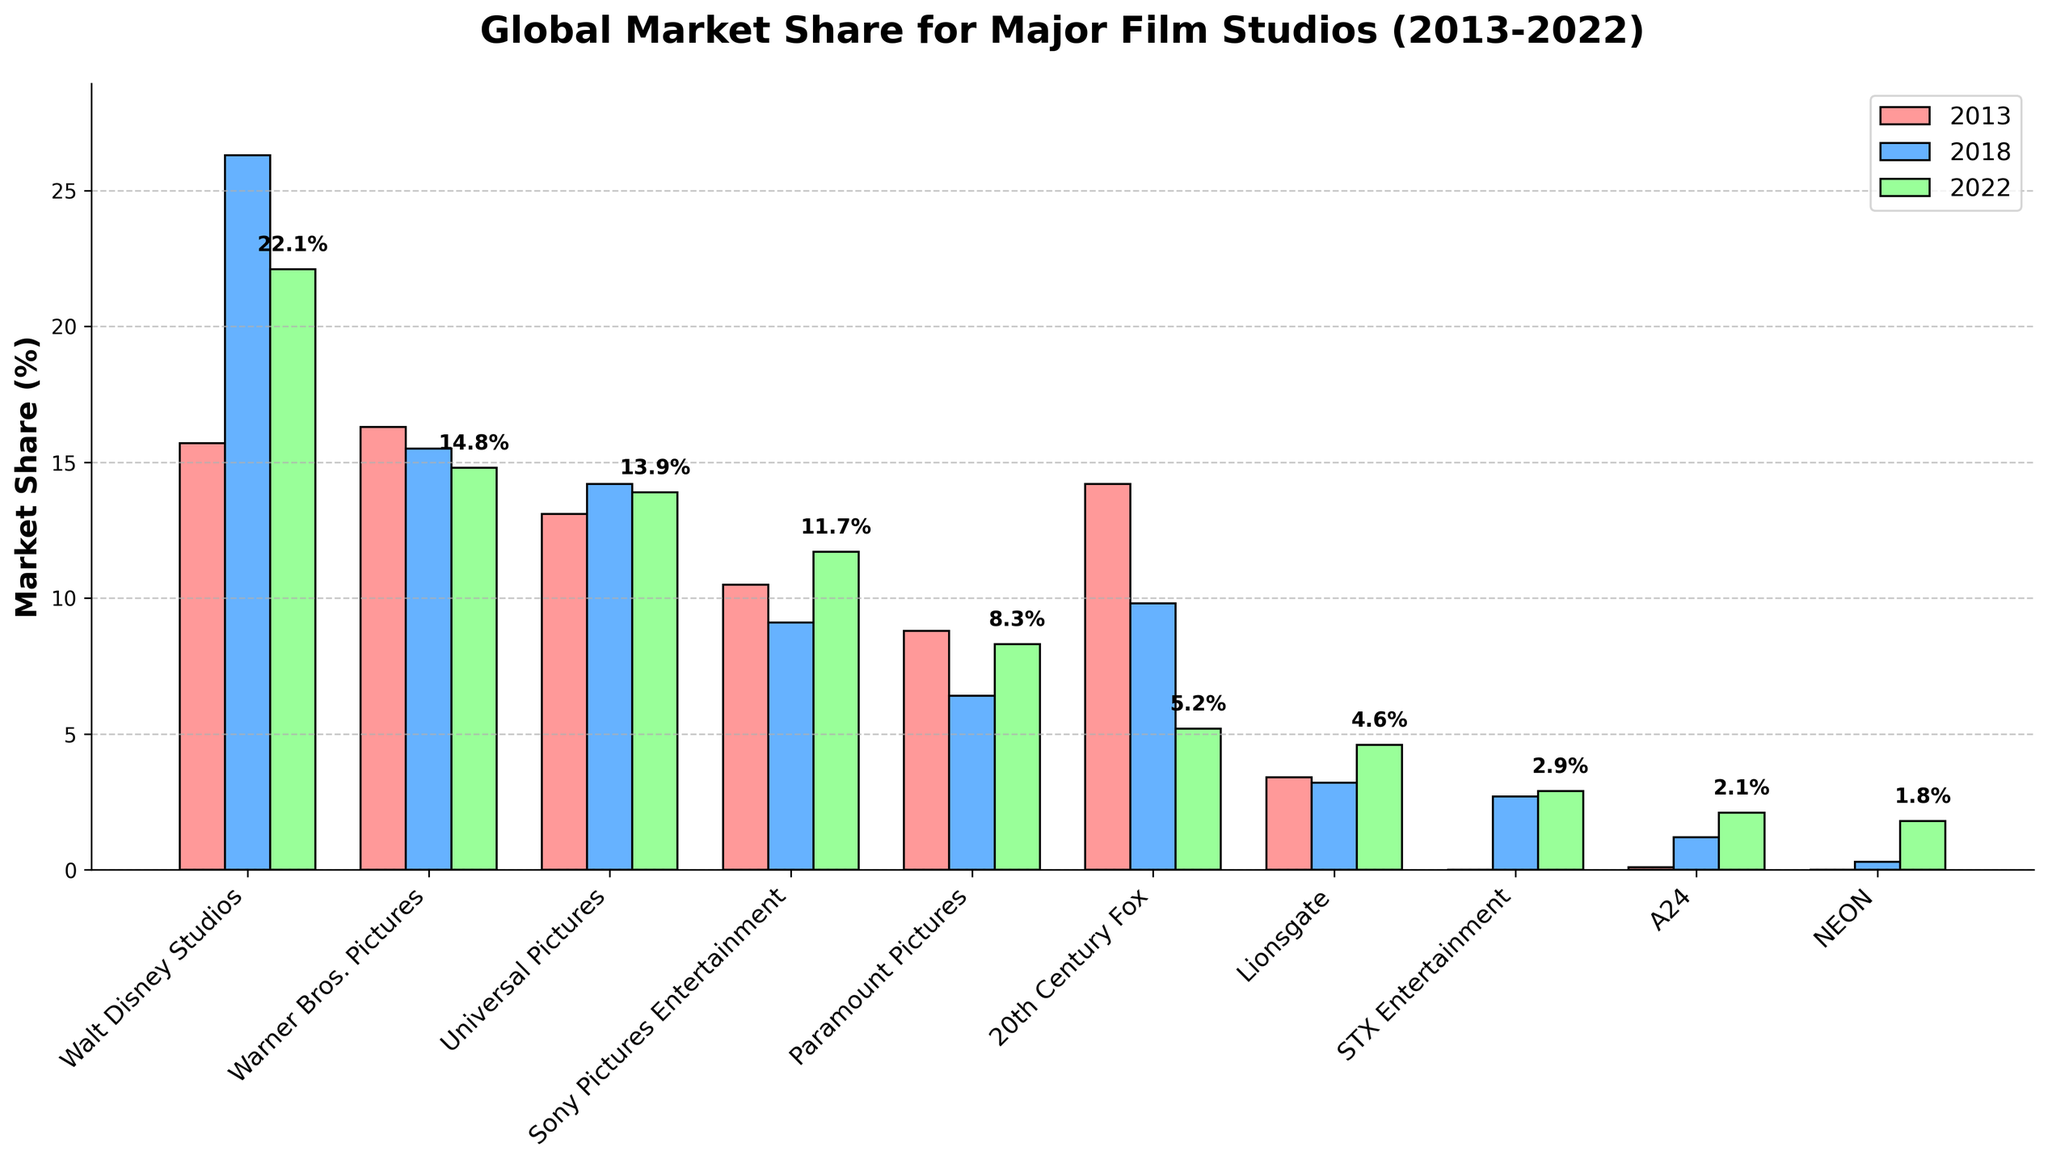Which studio had the highest market share in 2018? The blue bars represent data from 2018. Walt Disney Studios has the highest blue bar, indicating the largest market share.
Answer: Walt Disney Studios Which studios showed an increase in market share from 2013 to 2022? Compare the red (2013) and green (2022) bars. Studios that showed an increase in the height of the bars are Walt Disney Studios, Sony Pictures Entertainment, Paramount Pictures, STX Entertainment, A24, and NEON.
Answer: Walt Disney Studios, Sony Pictures Entertainment, Paramount Pictures, STX Entertainment, A24, NEON What is the combined market share of Warner Bros. Pictures and Universal Pictures in 2022? Look at the green bars for 2022 for both studios: Warner Bros. Pictures (14.8%) and Universal Pictures (13.9%). Summing these values: 14.8% + 13.9% = 28.7%.
Answer: 28.7% Which studio had the most significant decrease in market share from 2013 to 2022? Compare the red and green bars. 20th Century Fox decreased from 14.2% in 2013 to 5.2% in 2022, a decrease of 9%.
Answer: 20th Century Fox Which studio's market share was consistent across all three years? Compare bars of the same color (red, blue, green) across three years. Lionsgate's market shares remain very consistent (3.4%, 3.2%, and 4.6%).
Answer: Lionsgate How did the market share trend for Walt Disney Studios change over the decade? Examine the heights of the bars for Walt Disney Studios across the years. In 2013, the red bar is much lower (15.7%). The blue bar in 2018 increases significantly to 26.3%, but the green bar in 2022 slightly drops to 22.1%.
Answer: Increase then slight decrease What is the total market share of the top 3 studios in 2022? Identify the three green bars with the highest values: Walt Disney Studios (22.1%), Warner Bros. Pictures (14.8%), Universal Pictures (13.9%). Summing these values: 22.1% + 14.8% + 13.9% = 50.8%.
Answer: 50.8% Which studio had a market share of near 0% in 2013 but showed a significant increase by 2022? Identify studios with very low red bars in 2013 and higher green bars in 2022. NEON (0% in 2013 and 1.8% in 2022) and A24 (0.1% in 2013 and 2.1% in 2022) showed such trends.
Answer: NEON, A24 